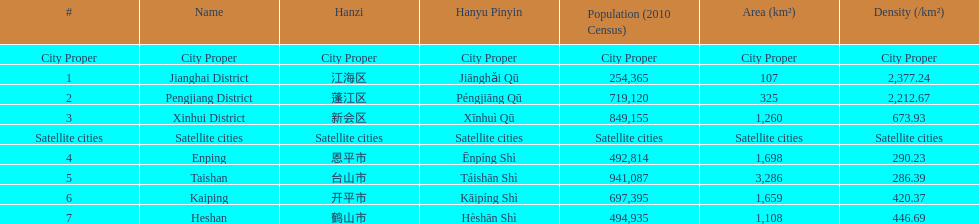What city proper has the smallest area in km2? Jianghai District. 